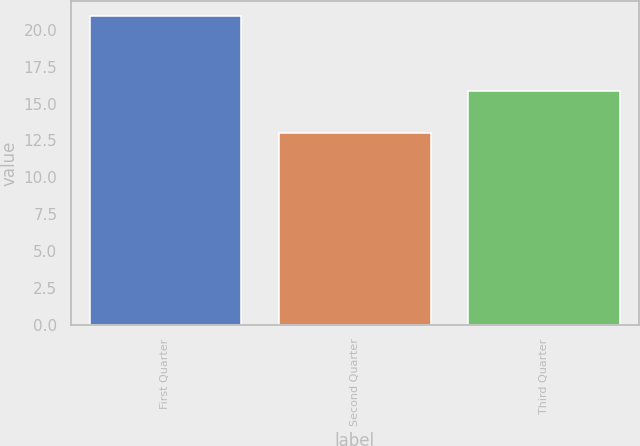Convert chart to OTSL. <chart><loc_0><loc_0><loc_500><loc_500><bar_chart><fcel>First Quarter<fcel>Second Quarter<fcel>Third Quarter<nl><fcel>20.9<fcel>12.98<fcel>15.87<nl></chart> 